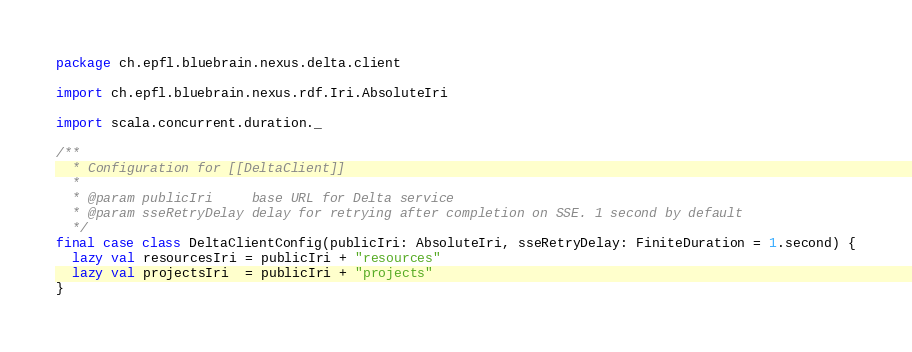<code> <loc_0><loc_0><loc_500><loc_500><_Scala_>package ch.epfl.bluebrain.nexus.delta.client

import ch.epfl.bluebrain.nexus.rdf.Iri.AbsoluteIri

import scala.concurrent.duration._

/**
  * Configuration for [[DeltaClient]]
  *
  * @param publicIri     base URL for Delta service
  * @param sseRetryDelay delay for retrying after completion on SSE. 1 second by default
  */
final case class DeltaClientConfig(publicIri: AbsoluteIri, sseRetryDelay: FiniteDuration = 1.second) {
  lazy val resourcesIri = publicIri + "resources"
  lazy val projectsIri  = publicIri + "projects"
}
</code> 